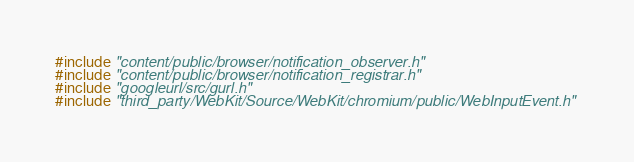<code> <loc_0><loc_0><loc_500><loc_500><_C_>#include "content/public/browser/notification_observer.h"
#include "content/public/browser/notification_registrar.h"
#include "googleurl/src/gurl.h"
#include "third_party/WebKit/Source/WebKit/chromium/public/WebInputEvent.h"</code> 